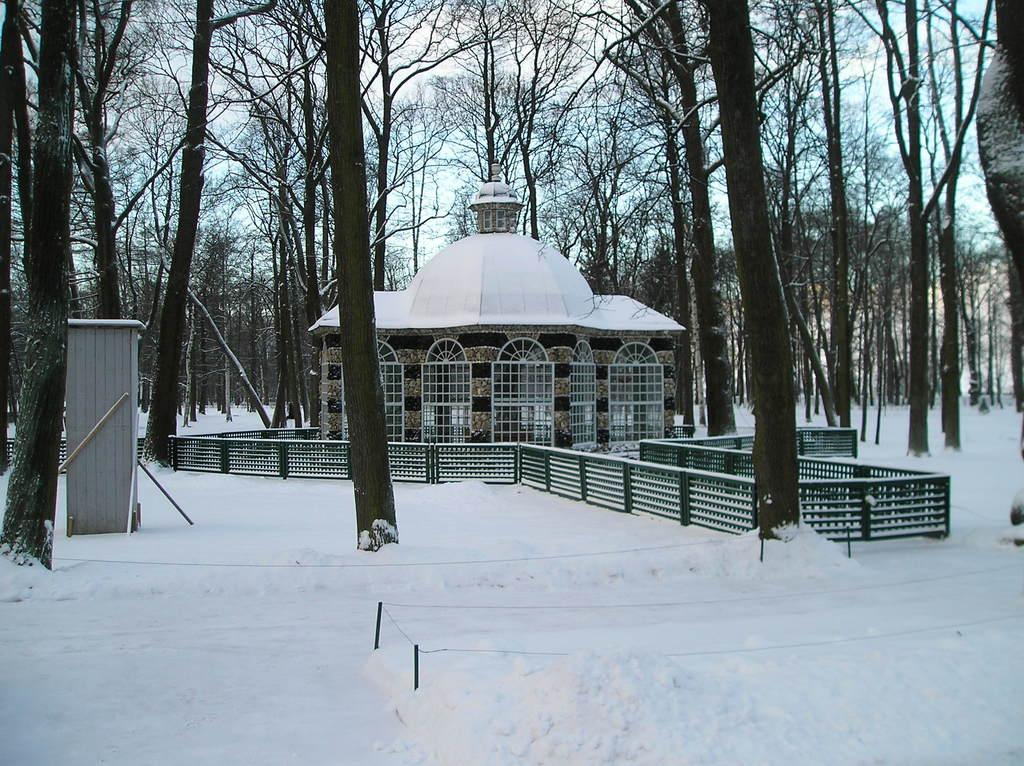What type of structure is visible in the image? There is a building in the image. What other natural elements can be seen in the image? There are trees in the image. What is the condition of the ground in the image? The ground is covered in snow in the image. How would you describe the sky in the image? The sky is cloudy in the image. What color are the crayons used to draw the pets in the image? There are no crayons or pets present in the image; it features a building, trees, snow, and a cloudy sky. 